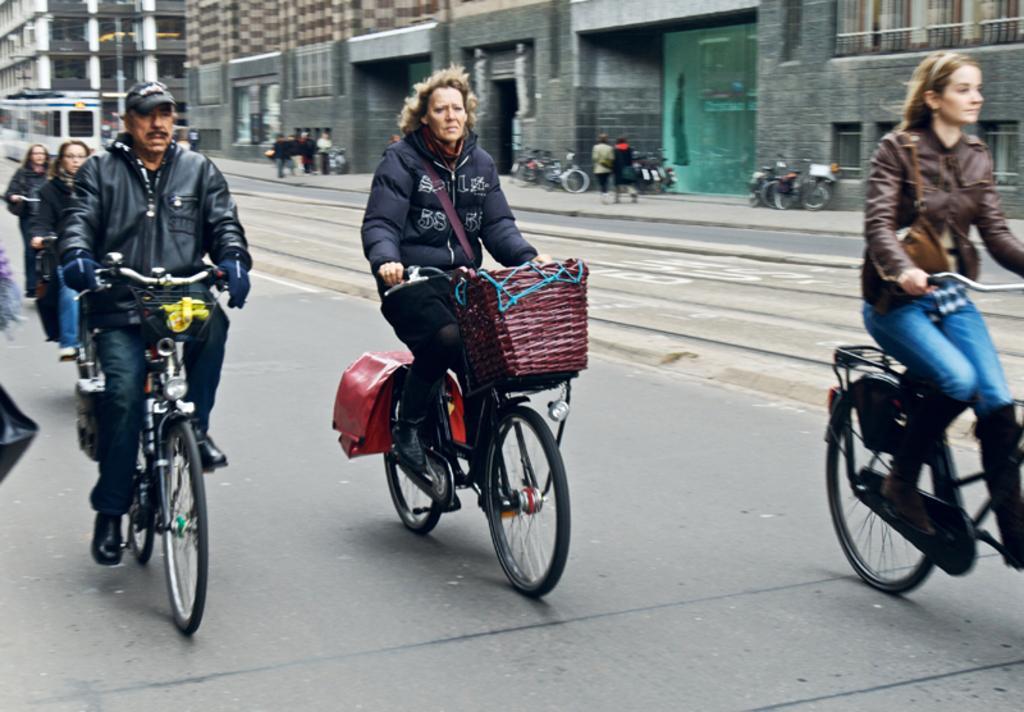Could you give a brief overview of what you see in this image? In the image we can see there are people who are riding bicycle on the road and beside them there is a building and bicycles are parked on the road. 